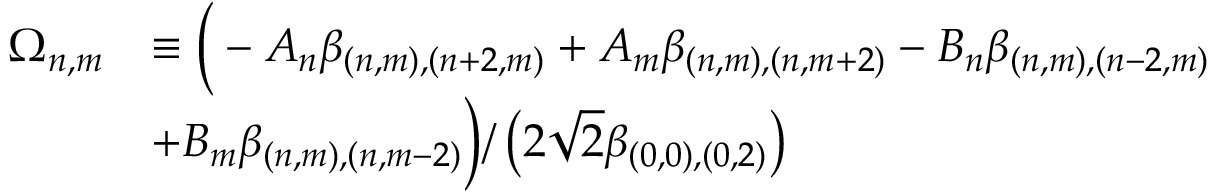<formula> <loc_0><loc_0><loc_500><loc_500>\begin{array} { r l } { \Omega _ { n , m } } & { \equiv \left ( - A _ { n } \beta _ { ( n , m ) , ( n + 2 , m ) } + A _ { m } \beta _ { ( n , m ) , ( n , m + 2 ) } - B _ { n } \beta _ { ( n , m ) , ( n - 2 , m ) } } \\ & { + B _ { m } \beta _ { ( n , m ) , ( n , m - 2 ) } \right ) / \left ( 2 \sqrt { 2 } \beta _ { ( 0 , 0 ) , ( 0 , 2 ) } \right ) } \end{array}</formula> 